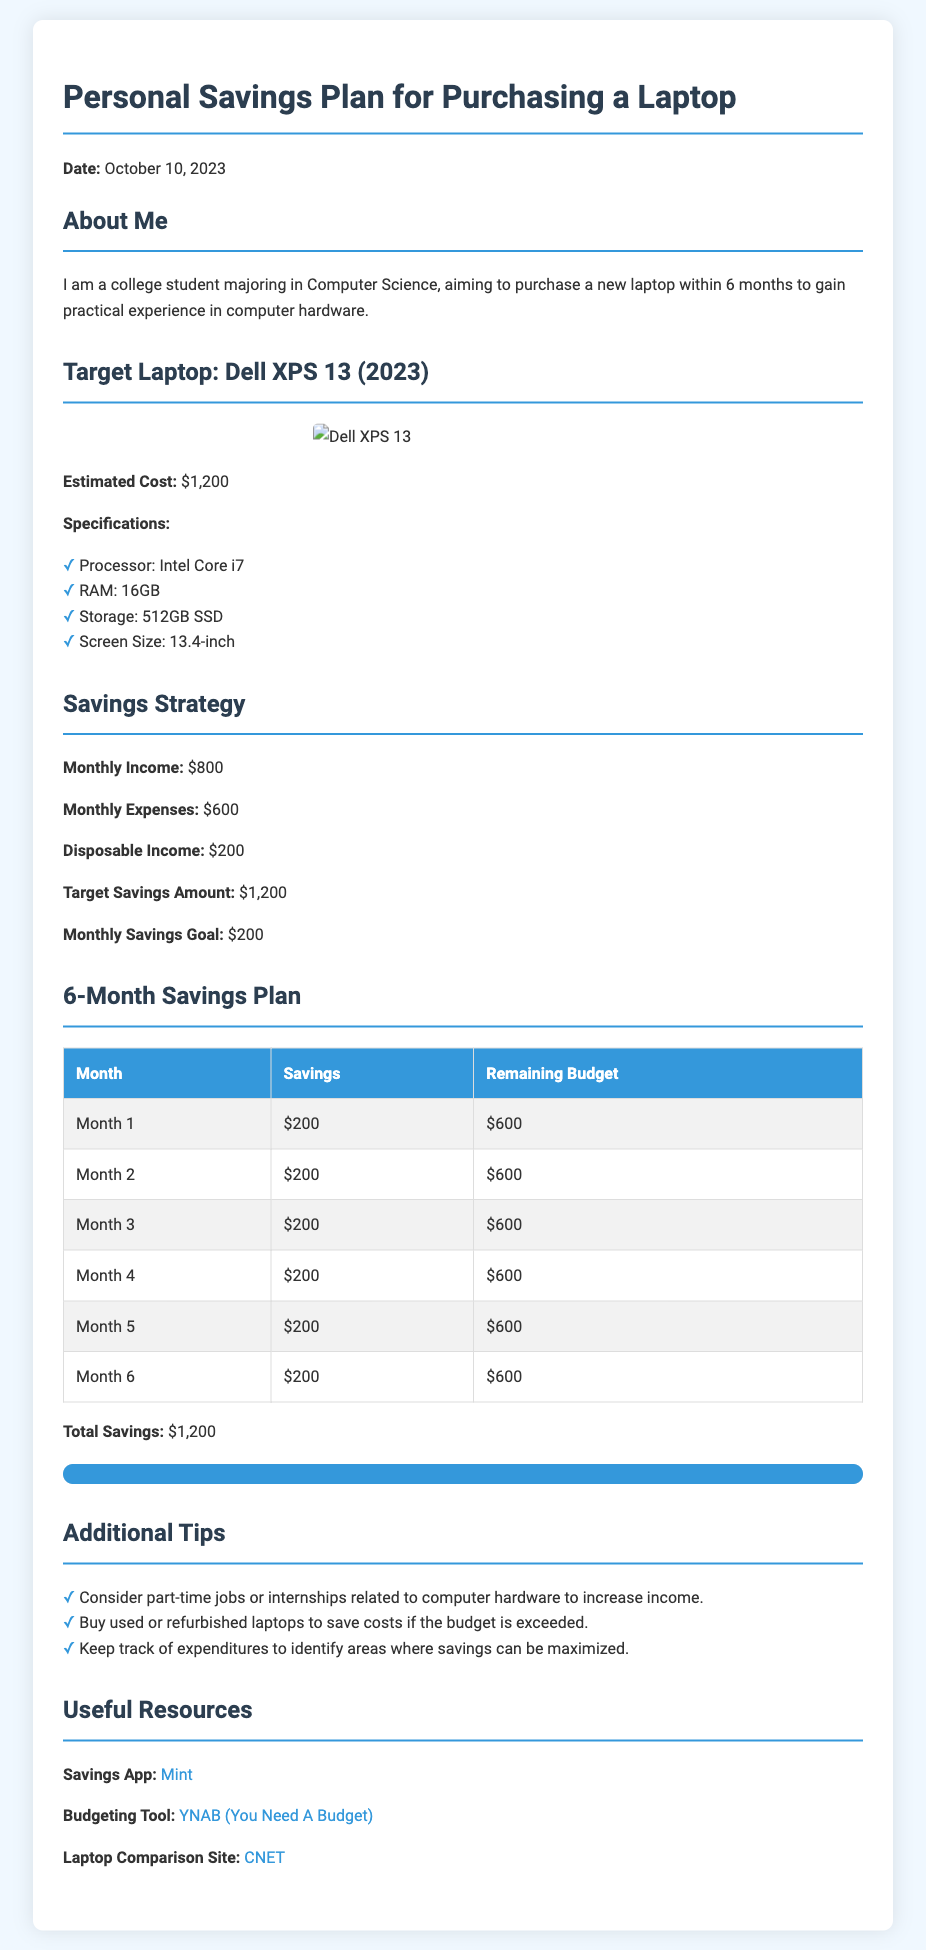What is the target laptop model? The target laptop model mentioned in the document is the Dell XPS 13 (2023).
Answer: Dell XPS 13 (2023) What is the estimated cost of the laptop? The estimated cost of the laptop is provided in the document as $1,200.
Answer: $1,200 What is the monthly disposable income? The monthly disposable income is calculated based on monthly income and expenses mentioned in the document, which is $800 - $600.
Answer: $200 What is the total savings over six months? Total savings is the sum of monthly savings goals over six months: $200 multiplied by 6.
Answer: $1,200 How many months is the savings plan for? The savings plan duration is specified in the document as six months.
Answer: Six months What should the monthly savings goal be? The monthly savings goal is clearly stated in the document as $200.
Answer: $200 What is one additional tip provided in the document? The document lists various tips; an example is considering part-time jobs or internships to increase income.
Answer: Consider part-time jobs What resource is suggested for budgeting? The document recommends a budgeting tool, specifically YNAB (You Need A Budget).
Answer: YNAB (You Need A Budget) What is the monthly income? The monthly income is outlined in the document as $800.
Answer: $800 